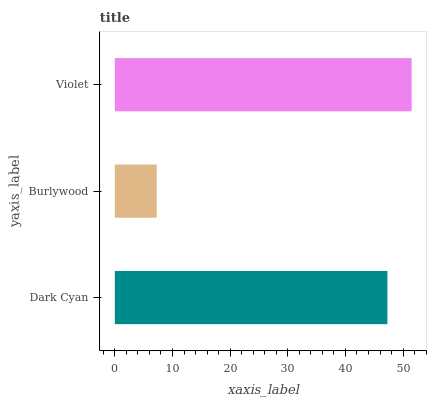Is Burlywood the minimum?
Answer yes or no. Yes. Is Violet the maximum?
Answer yes or no. Yes. Is Violet the minimum?
Answer yes or no. No. Is Burlywood the maximum?
Answer yes or no. No. Is Violet greater than Burlywood?
Answer yes or no. Yes. Is Burlywood less than Violet?
Answer yes or no. Yes. Is Burlywood greater than Violet?
Answer yes or no. No. Is Violet less than Burlywood?
Answer yes or no. No. Is Dark Cyan the high median?
Answer yes or no. Yes. Is Dark Cyan the low median?
Answer yes or no. Yes. Is Burlywood the high median?
Answer yes or no. No. Is Burlywood the low median?
Answer yes or no. No. 